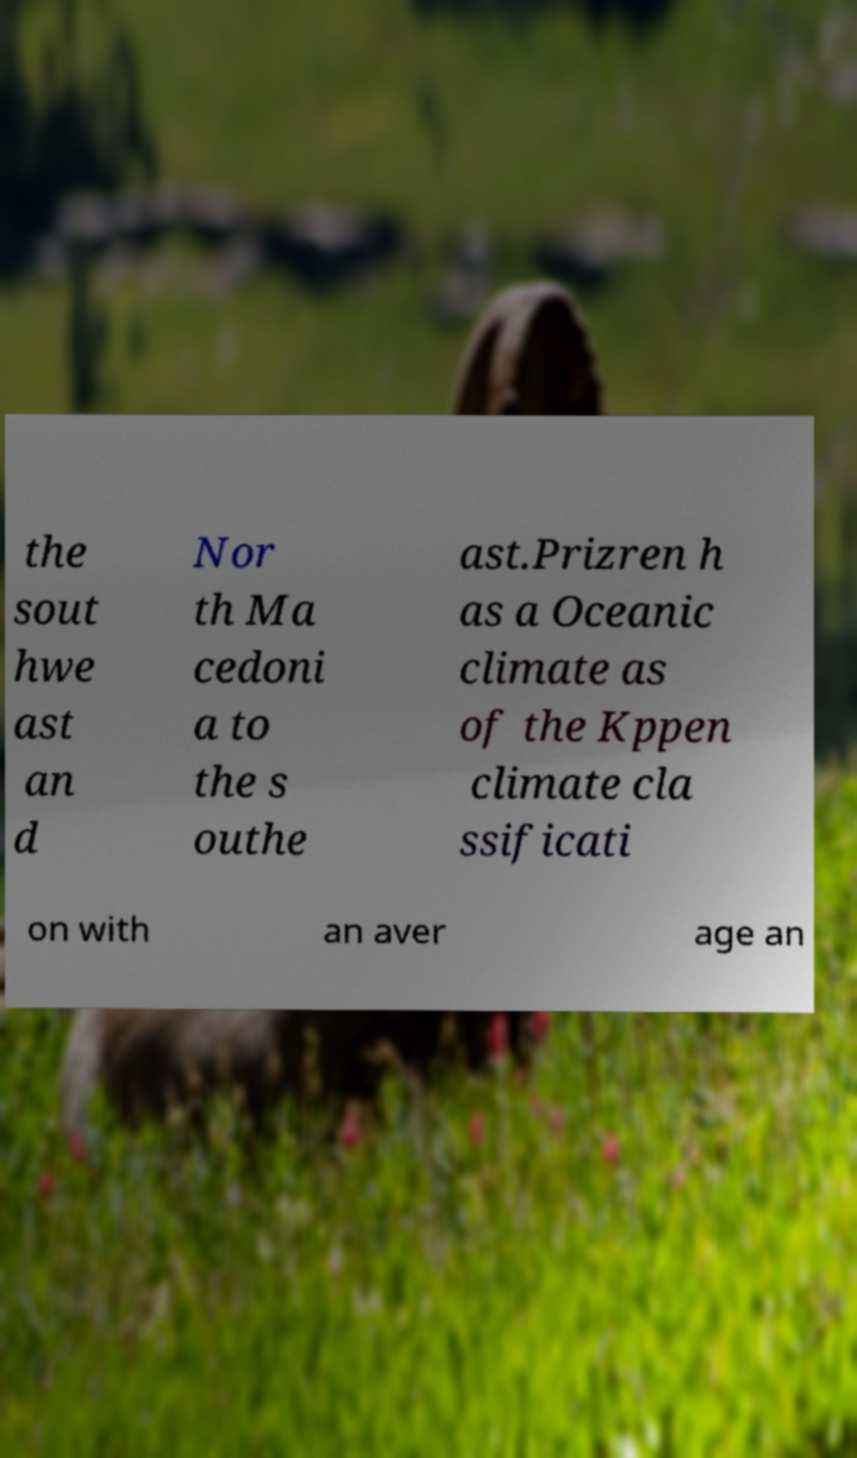Please identify and transcribe the text found in this image. the sout hwe ast an d Nor th Ma cedoni a to the s outhe ast.Prizren h as a Oceanic climate as of the Kppen climate cla ssificati on with an aver age an 